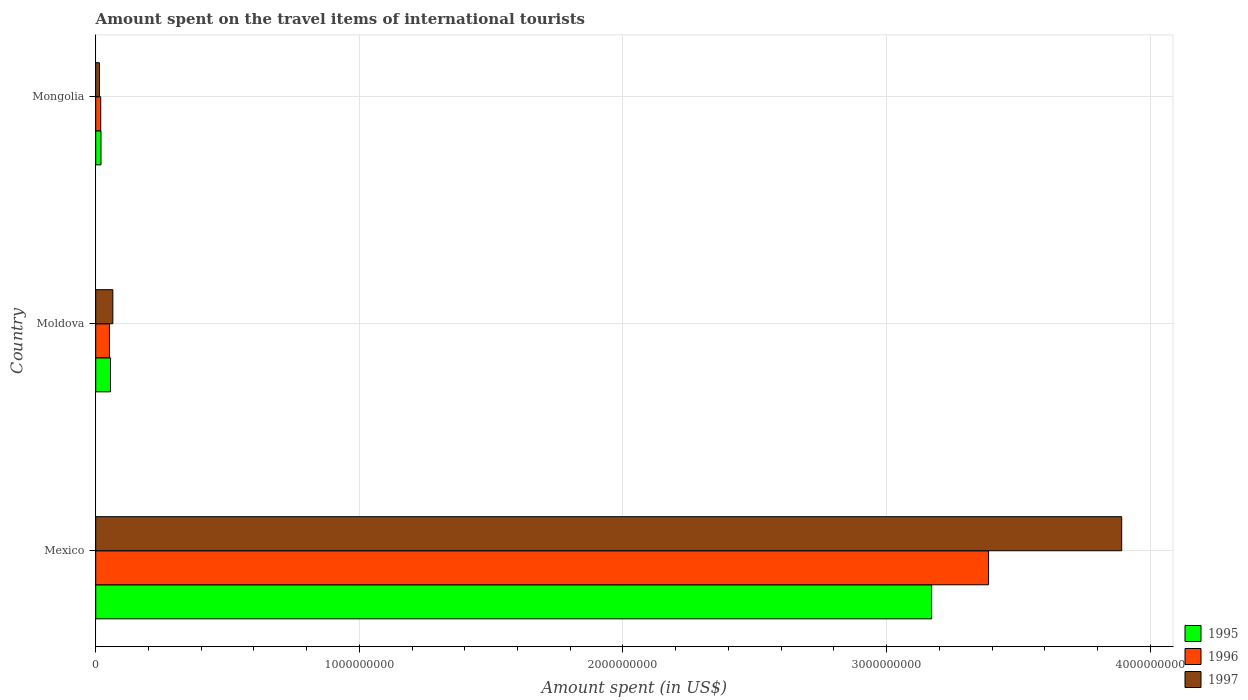How many different coloured bars are there?
Provide a succinct answer. 3. Are the number of bars per tick equal to the number of legend labels?
Give a very brief answer. Yes. How many bars are there on the 1st tick from the top?
Give a very brief answer. 3. How many bars are there on the 3rd tick from the bottom?
Offer a very short reply. 3. What is the amount spent on the travel items of international tourists in 1996 in Mexico?
Offer a very short reply. 3.39e+09. Across all countries, what is the maximum amount spent on the travel items of international tourists in 1996?
Provide a succinct answer. 3.39e+09. In which country was the amount spent on the travel items of international tourists in 1996 minimum?
Your response must be concise. Mongolia. What is the total amount spent on the travel items of international tourists in 1995 in the graph?
Offer a terse response. 3.25e+09. What is the difference between the amount spent on the travel items of international tourists in 1997 in Mexico and that in Mongolia?
Provide a short and direct response. 3.88e+09. What is the difference between the amount spent on the travel items of international tourists in 1996 in Moldova and the amount spent on the travel items of international tourists in 1997 in Mexico?
Your response must be concise. -3.84e+09. What is the average amount spent on the travel items of international tourists in 1997 per country?
Make the answer very short. 1.32e+09. What is the difference between the amount spent on the travel items of international tourists in 1995 and amount spent on the travel items of international tourists in 1997 in Moldova?
Provide a short and direct response. -9.00e+06. In how many countries, is the amount spent on the travel items of international tourists in 1995 greater than 3800000000 US$?
Your response must be concise. 0. What is the ratio of the amount spent on the travel items of international tourists in 1996 in Mexico to that in Moldova?
Provide a succinct answer. 65.13. What is the difference between the highest and the second highest amount spent on the travel items of international tourists in 1995?
Offer a terse response. 3.12e+09. What is the difference between the highest and the lowest amount spent on the travel items of international tourists in 1996?
Your response must be concise. 3.37e+09. In how many countries, is the amount spent on the travel items of international tourists in 1995 greater than the average amount spent on the travel items of international tourists in 1995 taken over all countries?
Offer a very short reply. 1. Is the sum of the amount spent on the travel items of international tourists in 1997 in Mexico and Moldova greater than the maximum amount spent on the travel items of international tourists in 1996 across all countries?
Make the answer very short. Yes. What does the 3rd bar from the top in Mongolia represents?
Keep it short and to the point. 1995. Is it the case that in every country, the sum of the amount spent on the travel items of international tourists in 1997 and amount spent on the travel items of international tourists in 1996 is greater than the amount spent on the travel items of international tourists in 1995?
Provide a short and direct response. Yes. Are all the bars in the graph horizontal?
Your response must be concise. Yes. How many countries are there in the graph?
Offer a very short reply. 3. What is the difference between two consecutive major ticks on the X-axis?
Provide a succinct answer. 1.00e+09. Does the graph contain any zero values?
Keep it short and to the point. No. How are the legend labels stacked?
Offer a very short reply. Vertical. What is the title of the graph?
Your answer should be compact. Amount spent on the travel items of international tourists. What is the label or title of the X-axis?
Offer a very short reply. Amount spent (in US$). What is the label or title of the Y-axis?
Your response must be concise. Country. What is the Amount spent (in US$) of 1995 in Mexico?
Make the answer very short. 3.17e+09. What is the Amount spent (in US$) in 1996 in Mexico?
Give a very brief answer. 3.39e+09. What is the Amount spent (in US$) in 1997 in Mexico?
Offer a terse response. 3.89e+09. What is the Amount spent (in US$) in 1995 in Moldova?
Your answer should be very brief. 5.60e+07. What is the Amount spent (in US$) in 1996 in Moldova?
Provide a short and direct response. 5.20e+07. What is the Amount spent (in US$) in 1997 in Moldova?
Give a very brief answer. 6.50e+07. What is the Amount spent (in US$) of 1996 in Mongolia?
Give a very brief answer. 1.90e+07. What is the Amount spent (in US$) in 1997 in Mongolia?
Your answer should be compact. 1.40e+07. Across all countries, what is the maximum Amount spent (in US$) in 1995?
Make the answer very short. 3.17e+09. Across all countries, what is the maximum Amount spent (in US$) in 1996?
Make the answer very short. 3.39e+09. Across all countries, what is the maximum Amount spent (in US$) in 1997?
Give a very brief answer. 3.89e+09. Across all countries, what is the minimum Amount spent (in US$) in 1995?
Make the answer very short. 2.00e+07. Across all countries, what is the minimum Amount spent (in US$) of 1996?
Give a very brief answer. 1.90e+07. Across all countries, what is the minimum Amount spent (in US$) in 1997?
Ensure brevity in your answer.  1.40e+07. What is the total Amount spent (in US$) of 1995 in the graph?
Your answer should be very brief. 3.25e+09. What is the total Amount spent (in US$) of 1996 in the graph?
Keep it short and to the point. 3.46e+09. What is the total Amount spent (in US$) of 1997 in the graph?
Provide a succinct answer. 3.97e+09. What is the difference between the Amount spent (in US$) of 1995 in Mexico and that in Moldova?
Keep it short and to the point. 3.12e+09. What is the difference between the Amount spent (in US$) in 1996 in Mexico and that in Moldova?
Ensure brevity in your answer.  3.34e+09. What is the difference between the Amount spent (in US$) of 1997 in Mexico and that in Moldova?
Keep it short and to the point. 3.83e+09. What is the difference between the Amount spent (in US$) of 1995 in Mexico and that in Mongolia?
Offer a terse response. 3.15e+09. What is the difference between the Amount spent (in US$) in 1996 in Mexico and that in Mongolia?
Provide a short and direct response. 3.37e+09. What is the difference between the Amount spent (in US$) in 1997 in Mexico and that in Mongolia?
Make the answer very short. 3.88e+09. What is the difference between the Amount spent (in US$) in 1995 in Moldova and that in Mongolia?
Provide a short and direct response. 3.60e+07. What is the difference between the Amount spent (in US$) of 1996 in Moldova and that in Mongolia?
Keep it short and to the point. 3.30e+07. What is the difference between the Amount spent (in US$) in 1997 in Moldova and that in Mongolia?
Ensure brevity in your answer.  5.10e+07. What is the difference between the Amount spent (in US$) in 1995 in Mexico and the Amount spent (in US$) in 1996 in Moldova?
Provide a succinct answer. 3.12e+09. What is the difference between the Amount spent (in US$) of 1995 in Mexico and the Amount spent (in US$) of 1997 in Moldova?
Your response must be concise. 3.11e+09. What is the difference between the Amount spent (in US$) of 1996 in Mexico and the Amount spent (in US$) of 1997 in Moldova?
Offer a very short reply. 3.32e+09. What is the difference between the Amount spent (in US$) in 1995 in Mexico and the Amount spent (in US$) in 1996 in Mongolia?
Ensure brevity in your answer.  3.15e+09. What is the difference between the Amount spent (in US$) of 1995 in Mexico and the Amount spent (in US$) of 1997 in Mongolia?
Offer a very short reply. 3.16e+09. What is the difference between the Amount spent (in US$) of 1996 in Mexico and the Amount spent (in US$) of 1997 in Mongolia?
Provide a short and direct response. 3.37e+09. What is the difference between the Amount spent (in US$) of 1995 in Moldova and the Amount spent (in US$) of 1996 in Mongolia?
Keep it short and to the point. 3.70e+07. What is the difference between the Amount spent (in US$) of 1995 in Moldova and the Amount spent (in US$) of 1997 in Mongolia?
Your response must be concise. 4.20e+07. What is the difference between the Amount spent (in US$) in 1996 in Moldova and the Amount spent (in US$) in 1997 in Mongolia?
Ensure brevity in your answer.  3.80e+07. What is the average Amount spent (in US$) in 1995 per country?
Your response must be concise. 1.08e+09. What is the average Amount spent (in US$) of 1996 per country?
Your answer should be compact. 1.15e+09. What is the average Amount spent (in US$) in 1997 per country?
Provide a succinct answer. 1.32e+09. What is the difference between the Amount spent (in US$) in 1995 and Amount spent (in US$) in 1996 in Mexico?
Give a very brief answer. -2.16e+08. What is the difference between the Amount spent (in US$) of 1995 and Amount spent (in US$) of 1997 in Mexico?
Ensure brevity in your answer.  -7.21e+08. What is the difference between the Amount spent (in US$) in 1996 and Amount spent (in US$) in 1997 in Mexico?
Provide a succinct answer. -5.05e+08. What is the difference between the Amount spent (in US$) in 1995 and Amount spent (in US$) in 1996 in Moldova?
Offer a terse response. 4.00e+06. What is the difference between the Amount spent (in US$) in 1995 and Amount spent (in US$) in 1997 in Moldova?
Make the answer very short. -9.00e+06. What is the difference between the Amount spent (in US$) of 1996 and Amount spent (in US$) of 1997 in Moldova?
Provide a short and direct response. -1.30e+07. What is the ratio of the Amount spent (in US$) of 1995 in Mexico to that in Moldova?
Your answer should be compact. 56.62. What is the ratio of the Amount spent (in US$) in 1996 in Mexico to that in Moldova?
Keep it short and to the point. 65.13. What is the ratio of the Amount spent (in US$) of 1997 in Mexico to that in Moldova?
Ensure brevity in your answer.  59.88. What is the ratio of the Amount spent (in US$) of 1995 in Mexico to that in Mongolia?
Ensure brevity in your answer.  158.55. What is the ratio of the Amount spent (in US$) in 1996 in Mexico to that in Mongolia?
Your answer should be compact. 178.26. What is the ratio of the Amount spent (in US$) in 1997 in Mexico to that in Mongolia?
Your answer should be compact. 278. What is the ratio of the Amount spent (in US$) of 1995 in Moldova to that in Mongolia?
Give a very brief answer. 2.8. What is the ratio of the Amount spent (in US$) of 1996 in Moldova to that in Mongolia?
Give a very brief answer. 2.74. What is the ratio of the Amount spent (in US$) of 1997 in Moldova to that in Mongolia?
Provide a succinct answer. 4.64. What is the difference between the highest and the second highest Amount spent (in US$) in 1995?
Make the answer very short. 3.12e+09. What is the difference between the highest and the second highest Amount spent (in US$) in 1996?
Give a very brief answer. 3.34e+09. What is the difference between the highest and the second highest Amount spent (in US$) of 1997?
Offer a very short reply. 3.83e+09. What is the difference between the highest and the lowest Amount spent (in US$) of 1995?
Give a very brief answer. 3.15e+09. What is the difference between the highest and the lowest Amount spent (in US$) in 1996?
Provide a succinct answer. 3.37e+09. What is the difference between the highest and the lowest Amount spent (in US$) in 1997?
Your answer should be very brief. 3.88e+09. 